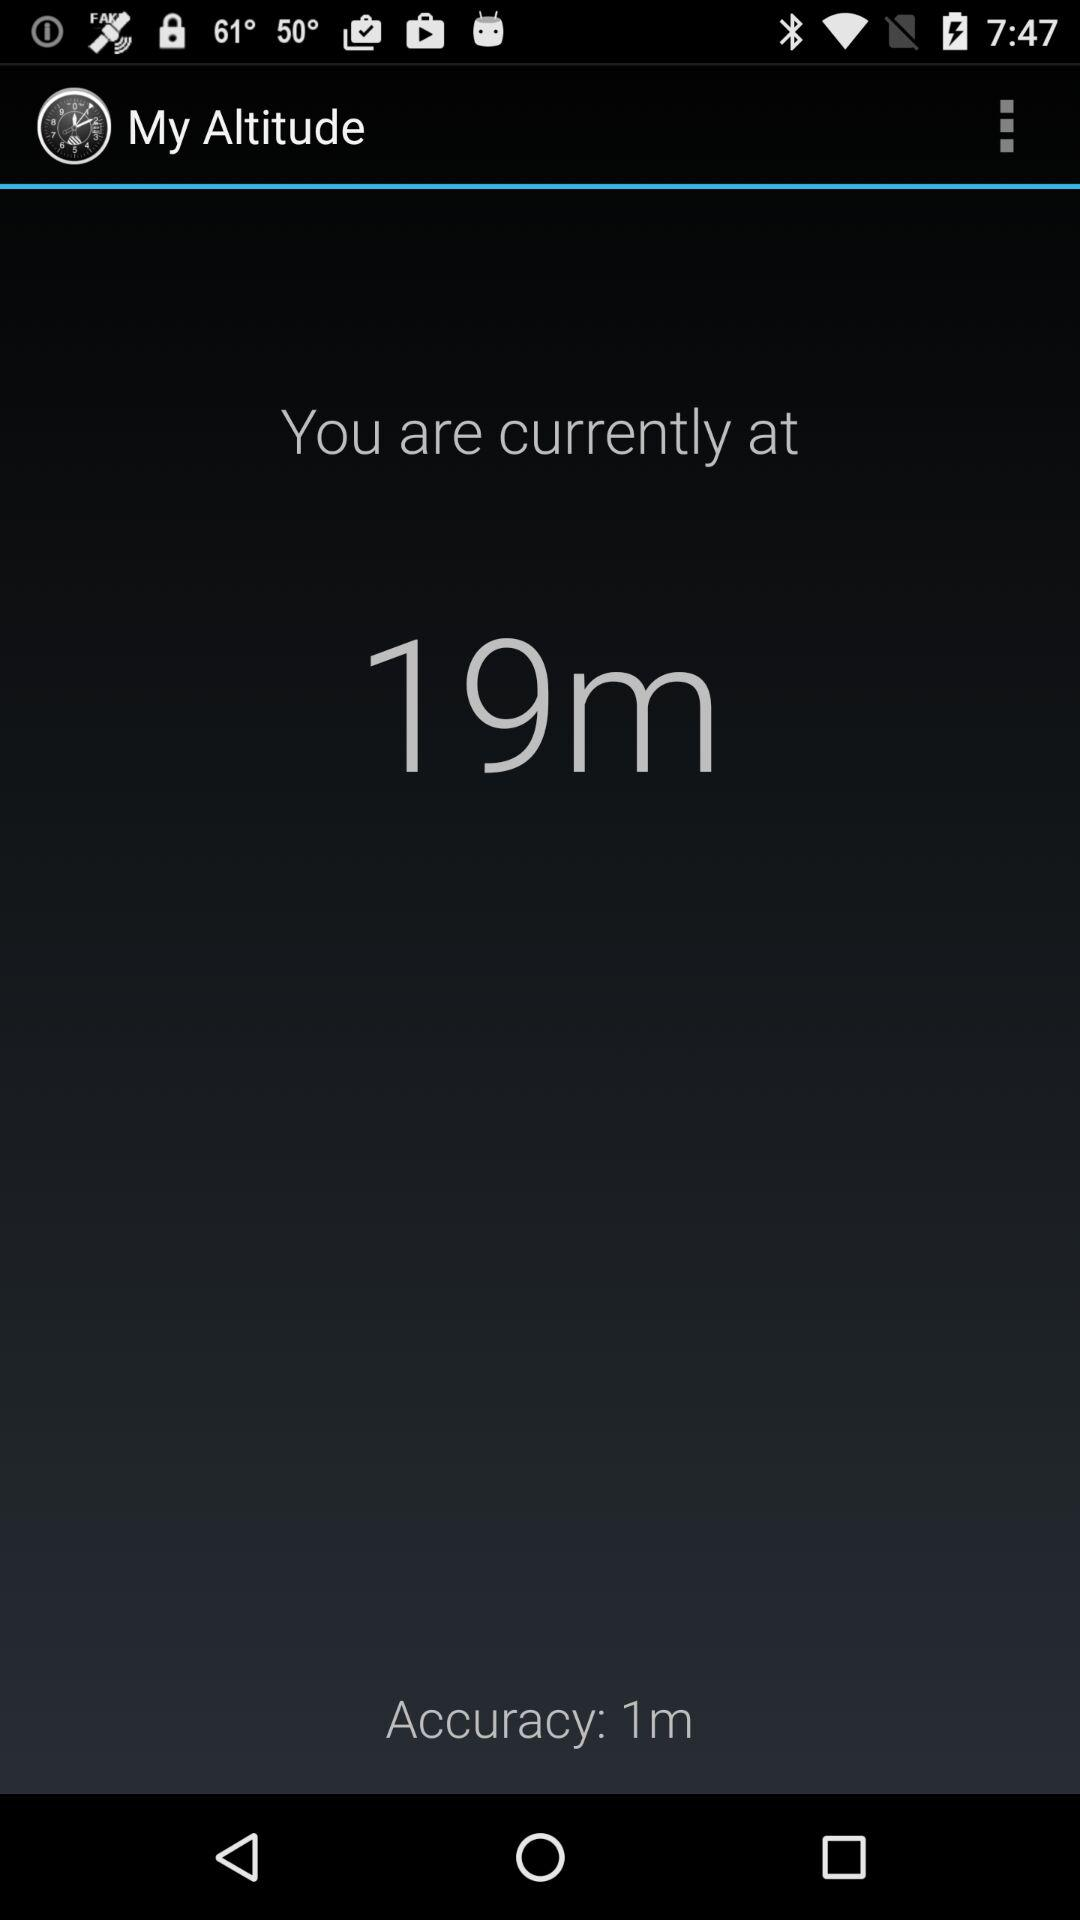How many meters above sea level am I?
Answer the question using a single word or phrase. 19m 